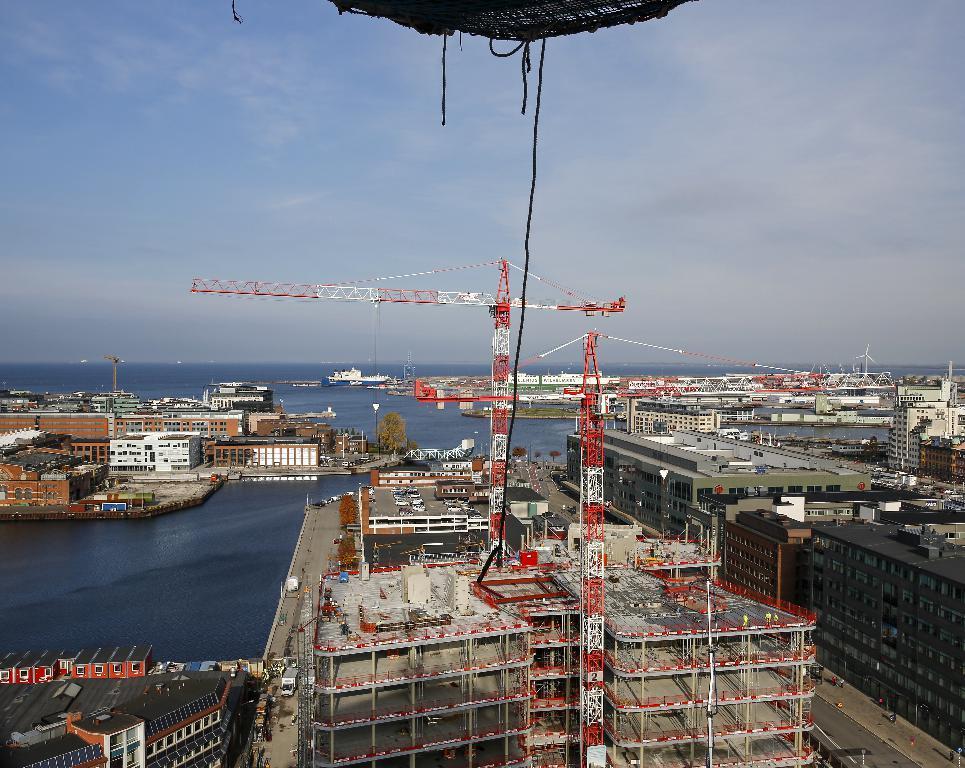In one or two sentences, can you explain what this image depicts? In this image, we can see some water in between buildings. There are cranes in the middle of the image. In the background of the image, there is a sky. 